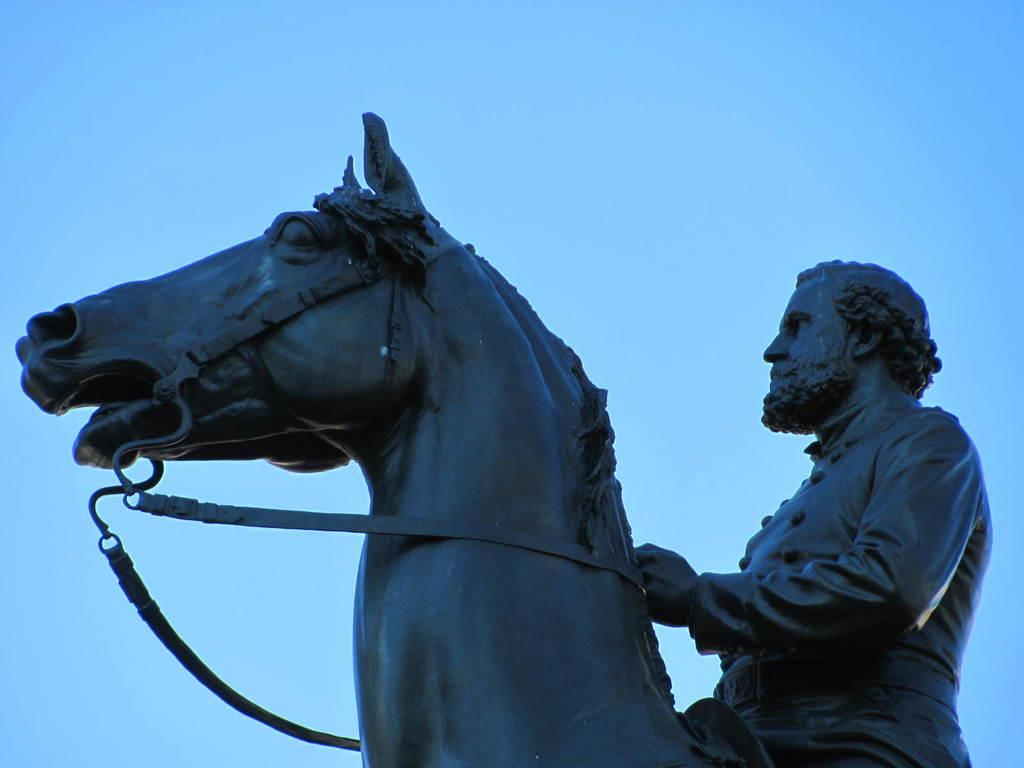What is the color of the sky in the image? The sky in the image is blue. What can be seen in the image besides the sky? There is a statue in the image. What is the statue of? The statue features a horse. Are there any unique features of the horse in the statue? Yes, the horse has stripes on it. Who is depicted on the horse in the statue? There is a man sitting on the horse in the statue. Are there any cobwebs visible on the statue in the image? There is no mention of cobwebs in the provided facts, and therefore we cannot determine if any are present in the image. 